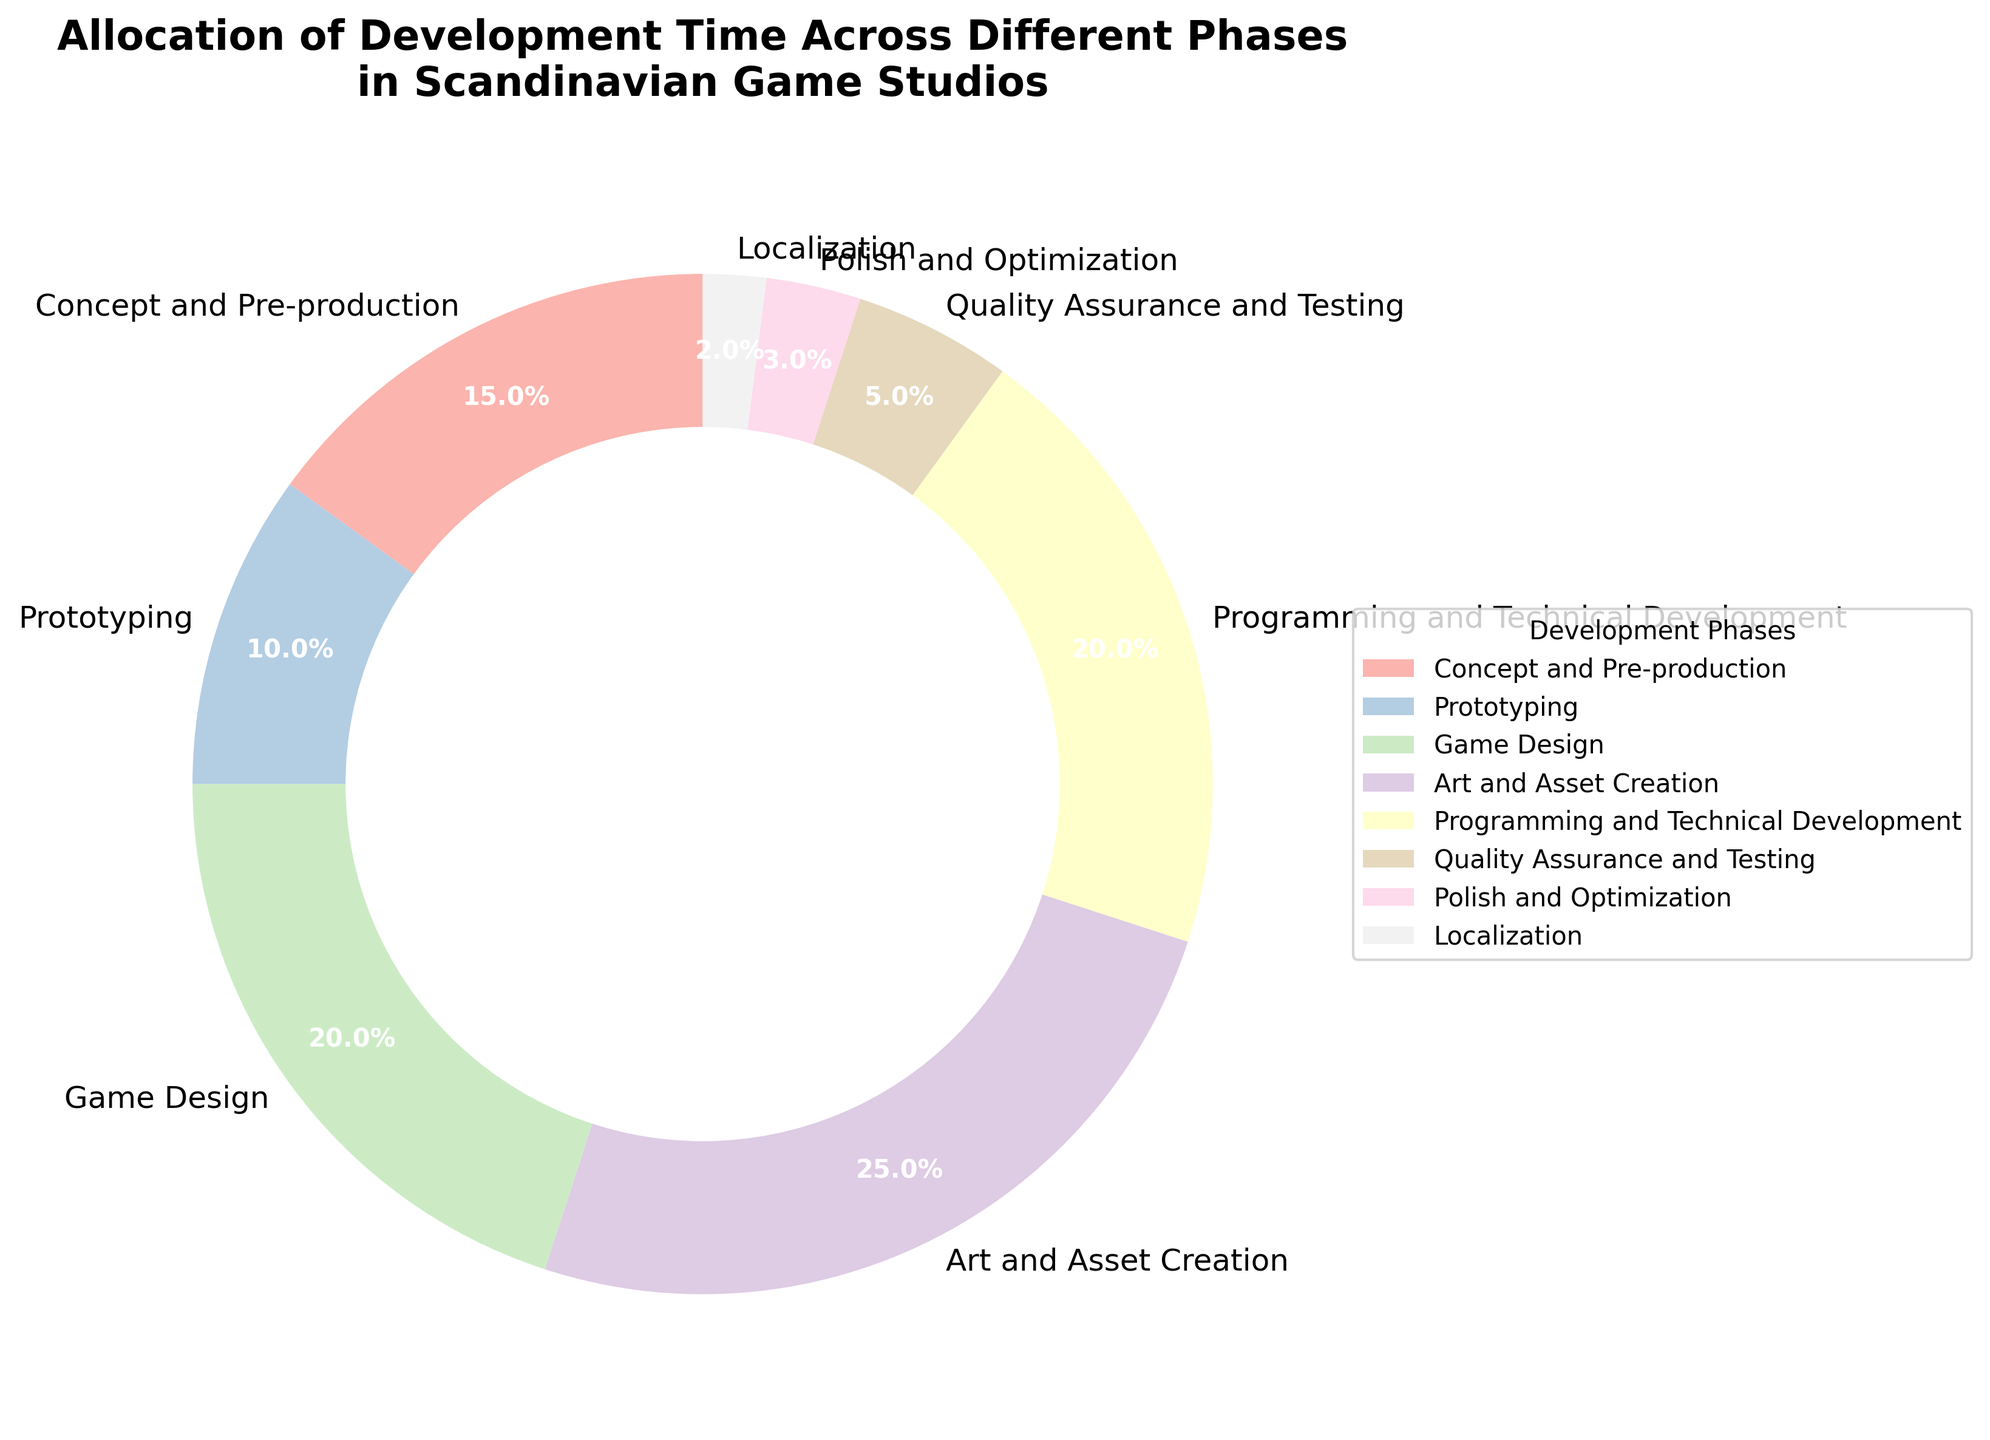What phase takes up the largest percentage of development time? To find the phase with the largest percentage, look at the slices of the pie chart and identify the slice with the highest value. The largest section is for Art and Asset Creation, which occupies 25%.
Answer: Art and Asset Creation Which phases together take up more than 50% of the development time? To determine which phases together exceed 50%, sum the percentages until the total surpasses 50%. Add the values for Art and Asset Creation (25%), Game Design (20%), and Programming and Technical Development (20%). The sum is 65%, which is more than 50%.
Answer: Art and Asset Creation, Game Design, and Programming and Technical Development How much more time is allocated to Programming and Technical Development compared to Quality Assurance and Testing? Subtract the percentage allocated to Quality Assurance and Testing from that allocated to Programming and Technical Development. Programming and Technical Development is 20%, and Quality Assurance and Testing is 5%. The difference is 20% - 5% = 15%.
Answer: 15% Which phase receives the least amount of development time? Look for the smallest slice in the pie chart. The smallest section is for Localization, which takes up 2% of the development time.
Answer: Localization How does the percentage of time allocated to Prototyping compare to the combined time for Polish and Optimization and Localization? First, find the combined percentage for Polish and Optimization (3%) and Localization (2%). Their total is 3% + 2% = 5%. Compare this to Prototyping's 10%. Prototyping has 5% more than the combined total of Polish and Optimization and Localization.
Answer: 5% more What is the combined percentage of development time spent on Concept and Pre-production and Game Design? Add the percentages for Concept and Pre-production (15%) and Game Design (20%). Their combined total is 15% + 20% = 35%.
Answer: 35% Is the time allocated to Art and Asset Creation greater than the time allocated to Game Design and Quality Assurance and Testing combined? Compare the percentage for Art and Asset Creation (25%) with the combined percentage of Game Design (20%) and Quality Assurance and Testing (5%). The combined time is 20% + 5% = 25%, which is equal to Art and Asset Creation's 25%.
Answer: equal How does the proportion of time dedicated to Polish and Optimization compare to the sum of Concept and Pre-production and Localization? First, find the sum of Concept and Pre-production (15%) and Localization (2%). Their total is 15% + 2% = 17%. Compare this with Polish and Optimization's 3%. Polish and Optimization has 14% less.
Answer: 14% less Which phases together take up exactly half of the development time? Find the combination of phases that sum up to 50%. The percentages for Art and Asset Creation (25%) and Programming and Technical Development (20%) combined with Polish and Optimization (3%) and Localization (2%) total 50%.
Answer: Art and Asset Creation, Programming and Technical Development, Polish and Optimization, Localization 